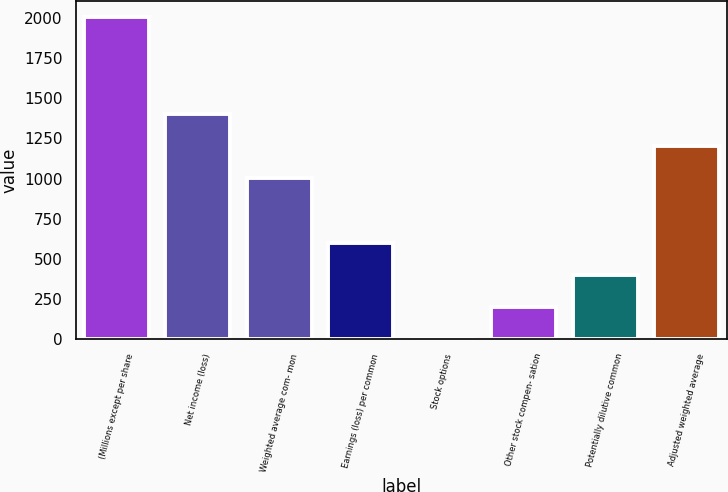<chart> <loc_0><loc_0><loc_500><loc_500><bar_chart><fcel>(Millions except per share<fcel>Net income (loss)<fcel>Weighted average com- mon<fcel>Earnings (loss) per common<fcel>Stock options<fcel>Other stock compen- sation<fcel>Potentially dilutive common<fcel>Adjusted weighted average<nl><fcel>2003<fcel>1402.16<fcel>1001.6<fcel>601.04<fcel>0.2<fcel>200.48<fcel>400.76<fcel>1201.88<nl></chart> 